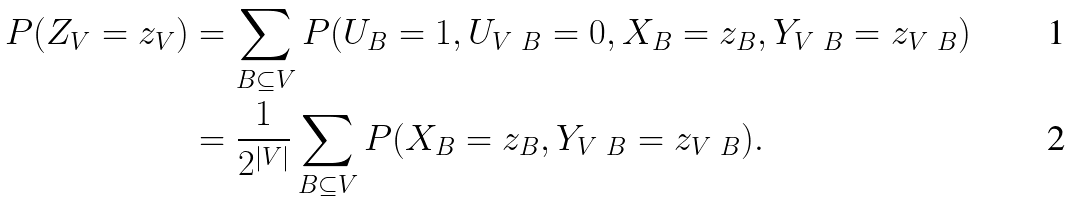Convert formula to latex. <formula><loc_0><loc_0><loc_500><loc_500>P ( Z _ { V } = z _ { V } ) & = \sum _ { B \subseteq V } P ( U _ { B } = 1 , U _ { V \ B } = 0 , X _ { B } = z _ { B } , Y _ { V \ B } = z _ { V \ B } ) \\ & = \frac { 1 } { 2 ^ { | V | } } \sum _ { B \subseteq V } P ( X _ { B } = z _ { B } , Y _ { V \ B } = z _ { V \ B } ) .</formula> 